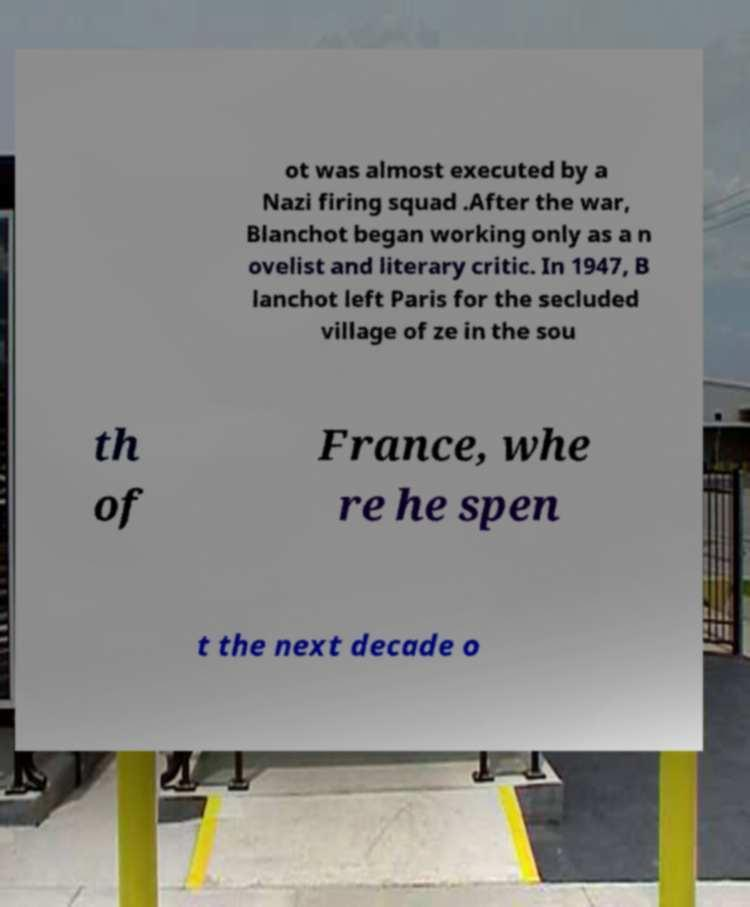Can you read and provide the text displayed in the image?This photo seems to have some interesting text. Can you extract and type it out for me? ot was almost executed by a Nazi firing squad .After the war, Blanchot began working only as a n ovelist and literary critic. In 1947, B lanchot left Paris for the secluded village of ze in the sou th of France, whe re he spen t the next decade o 